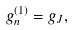<formula> <loc_0><loc_0><loc_500><loc_500>g _ { n } ^ { ( 1 ) } = g _ { J } ,</formula> 